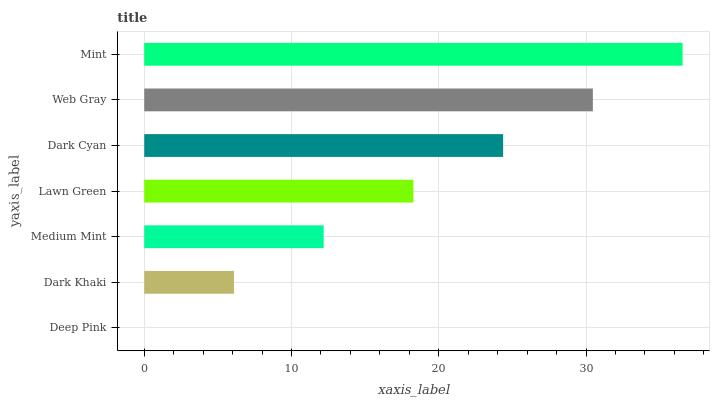Is Deep Pink the minimum?
Answer yes or no. Yes. Is Mint the maximum?
Answer yes or no. Yes. Is Dark Khaki the minimum?
Answer yes or no. No. Is Dark Khaki the maximum?
Answer yes or no. No. Is Dark Khaki greater than Deep Pink?
Answer yes or no. Yes. Is Deep Pink less than Dark Khaki?
Answer yes or no. Yes. Is Deep Pink greater than Dark Khaki?
Answer yes or no. No. Is Dark Khaki less than Deep Pink?
Answer yes or no. No. Is Lawn Green the high median?
Answer yes or no. Yes. Is Lawn Green the low median?
Answer yes or no. Yes. Is Web Gray the high median?
Answer yes or no. No. Is Mint the low median?
Answer yes or no. No. 